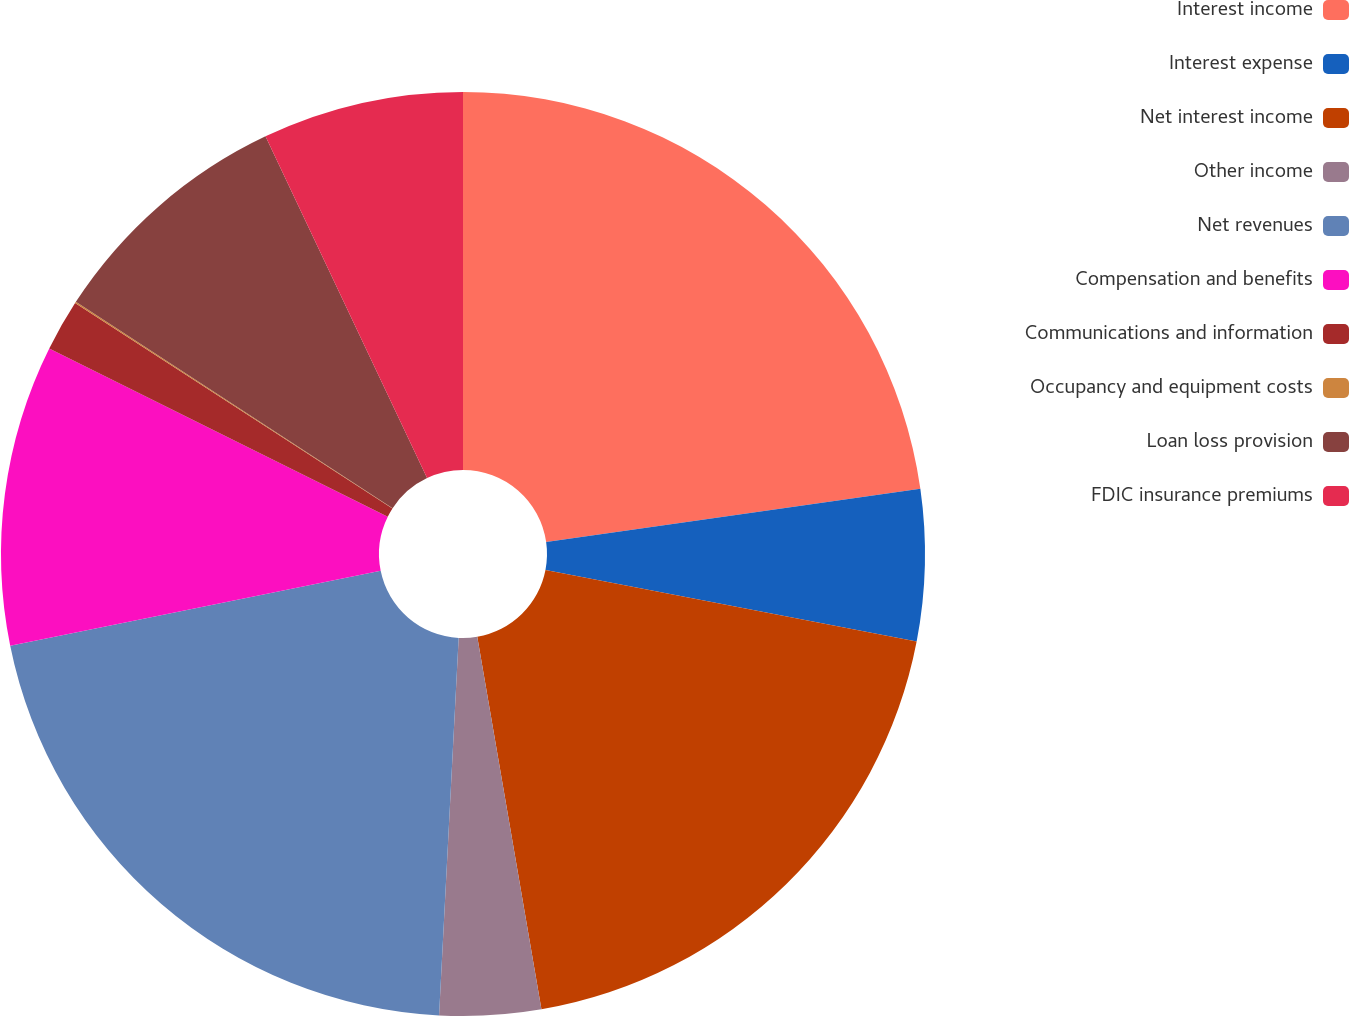<chart> <loc_0><loc_0><loc_500><loc_500><pie_chart><fcel>Interest income<fcel>Interest expense<fcel>Net interest income<fcel>Other income<fcel>Net revenues<fcel>Compensation and benefits<fcel>Communications and information<fcel>Occupancy and equipment costs<fcel>Loan loss provision<fcel>FDIC insurance premiums<nl><fcel>22.74%<fcel>5.29%<fcel>19.25%<fcel>3.54%<fcel>20.99%<fcel>10.52%<fcel>1.8%<fcel>0.05%<fcel>8.78%<fcel>7.03%<nl></chart> 